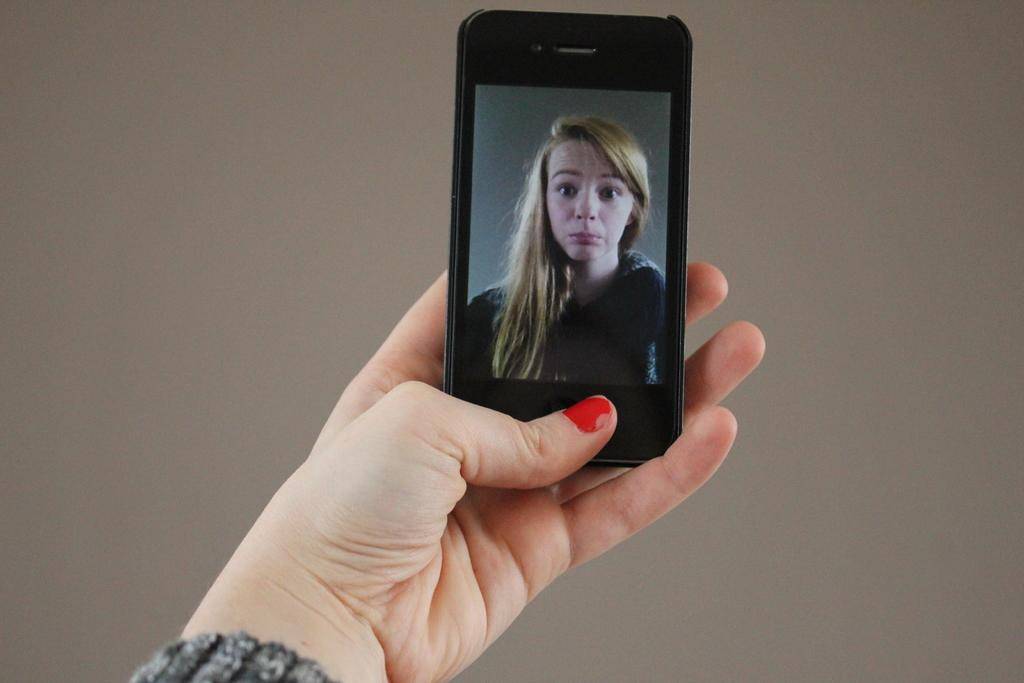What can be seen in the image? There is a person's hand in the image. What is the hand holding? The hand is holding a mobile phone. What is displayed on the mobile phone screen? There is a picture of a woman on the mobile phone screen. What type of shoe is the woman wearing in the image? There is no woman or shoe present in the image; it only shows a person's hand holding a mobile phone with a picture of a woman on the screen. 